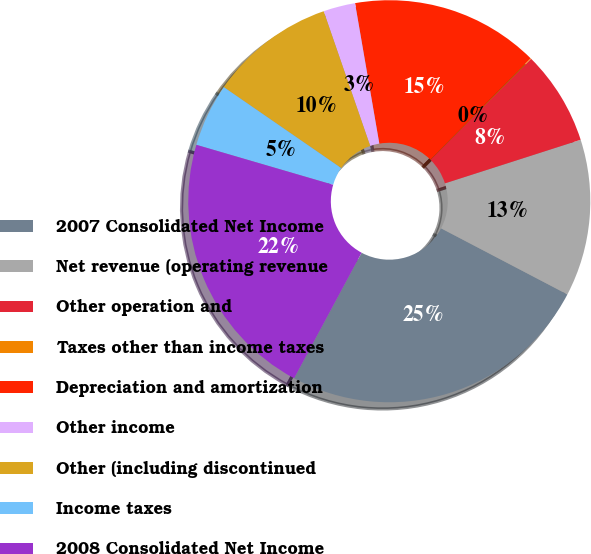<chart> <loc_0><loc_0><loc_500><loc_500><pie_chart><fcel>2007 Consolidated Net Income<fcel>Net revenue (operating revenue<fcel>Other operation and<fcel>Taxes other than income taxes<fcel>Depreciation and amortization<fcel>Other income<fcel>Other (including discontinued<fcel>Income taxes<fcel>2008 Consolidated Net Income<nl><fcel>25.18%<fcel>12.62%<fcel>7.59%<fcel>0.06%<fcel>15.13%<fcel>2.57%<fcel>10.1%<fcel>5.08%<fcel>21.68%<nl></chart> 